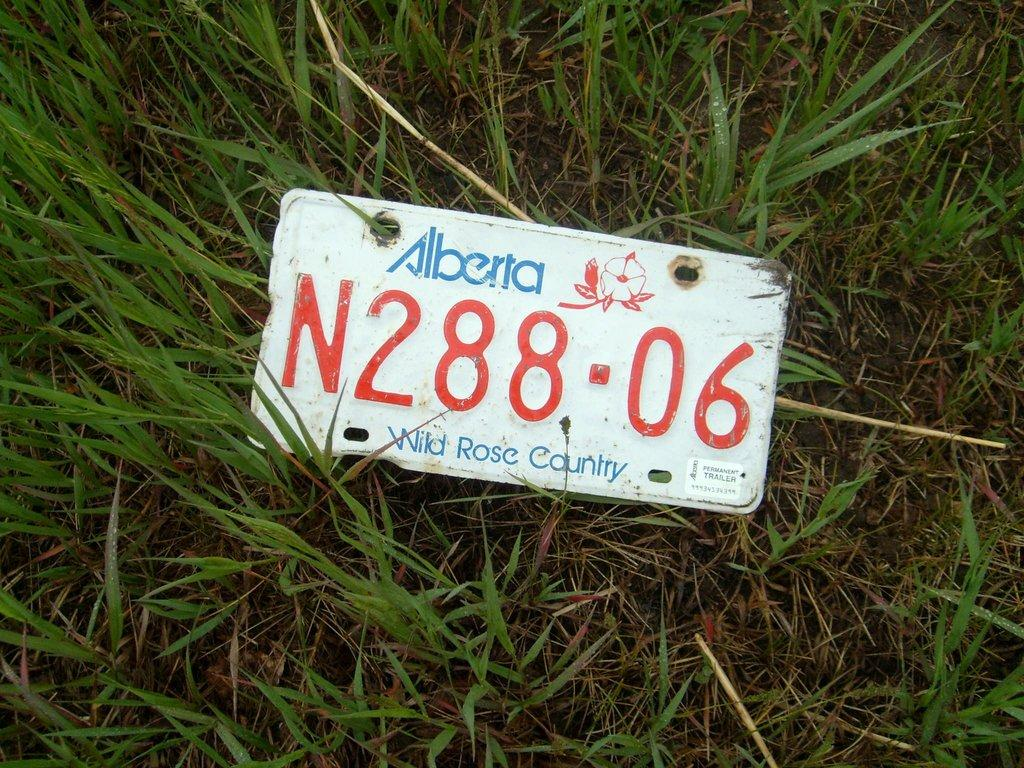What is the main object in the foreground of the image? There is a board with text in the image. Where is the board located in relation to the image? The board is in the front of the image. What type of surface can be seen on the ground in the image? There is grass on the ground in the image. Reasoning: Let' Let's think step by step in order to produce the conversation. We start by identifying the main subject of the image, which is the board with text. Then, we describe its location within the image, noting that it is in the front. Finally, we mention the type of ground surface visible in the image, which is grass. Each question is designed to elicit a specific detail about the image that is known from the provided facts. Absurd Question/Answer: What type of meat is being cooked on the grill in the image? There is no grill or meat present in the image; it features a board with text in the front and grass on the ground. What type of arch can be seen in the background of the image? There is no arch present in the image; it features a board with text in the front and grass on the ground. 